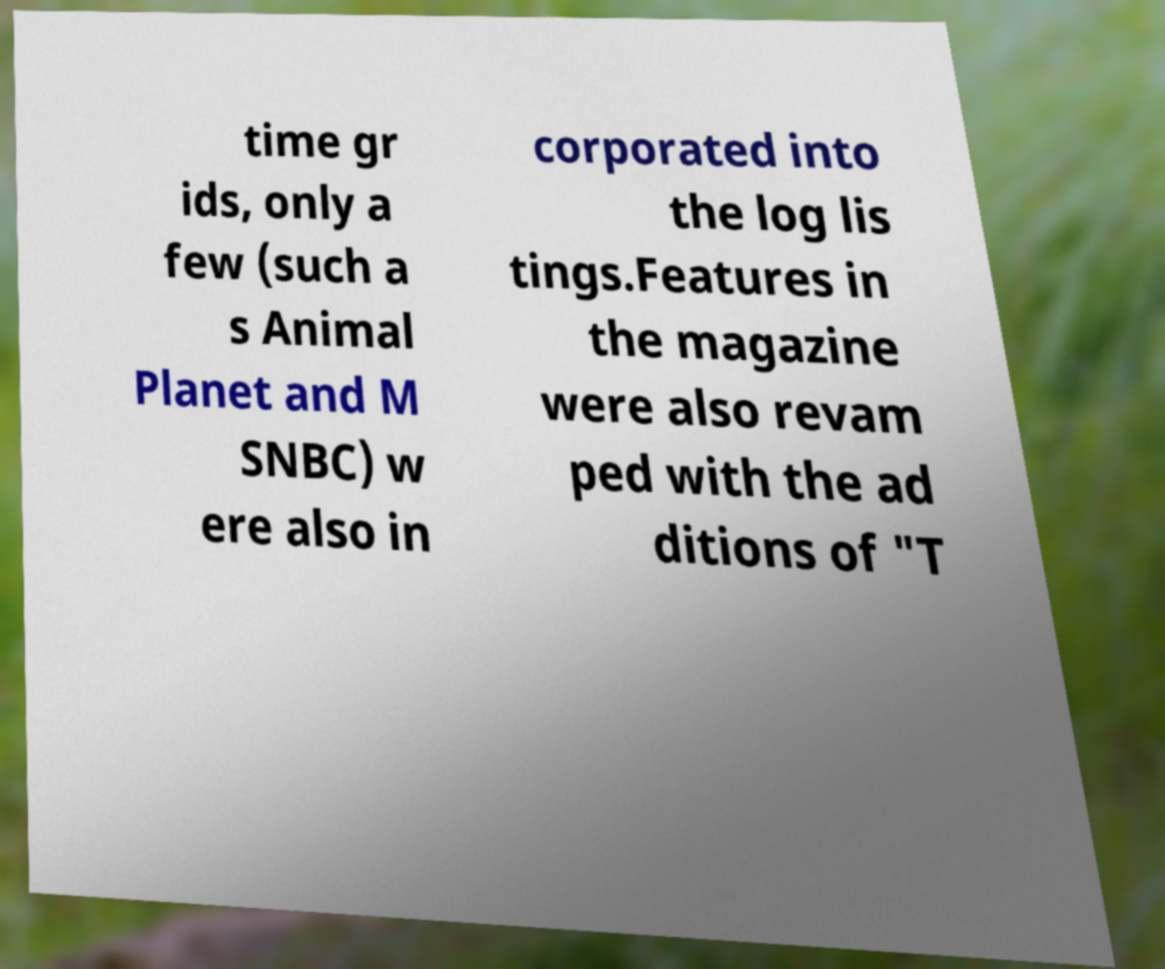For documentation purposes, I need the text within this image transcribed. Could you provide that? time gr ids, only a few (such a s Animal Planet and M SNBC) w ere also in corporated into the log lis tings.Features in the magazine were also revam ped with the ad ditions of "T 